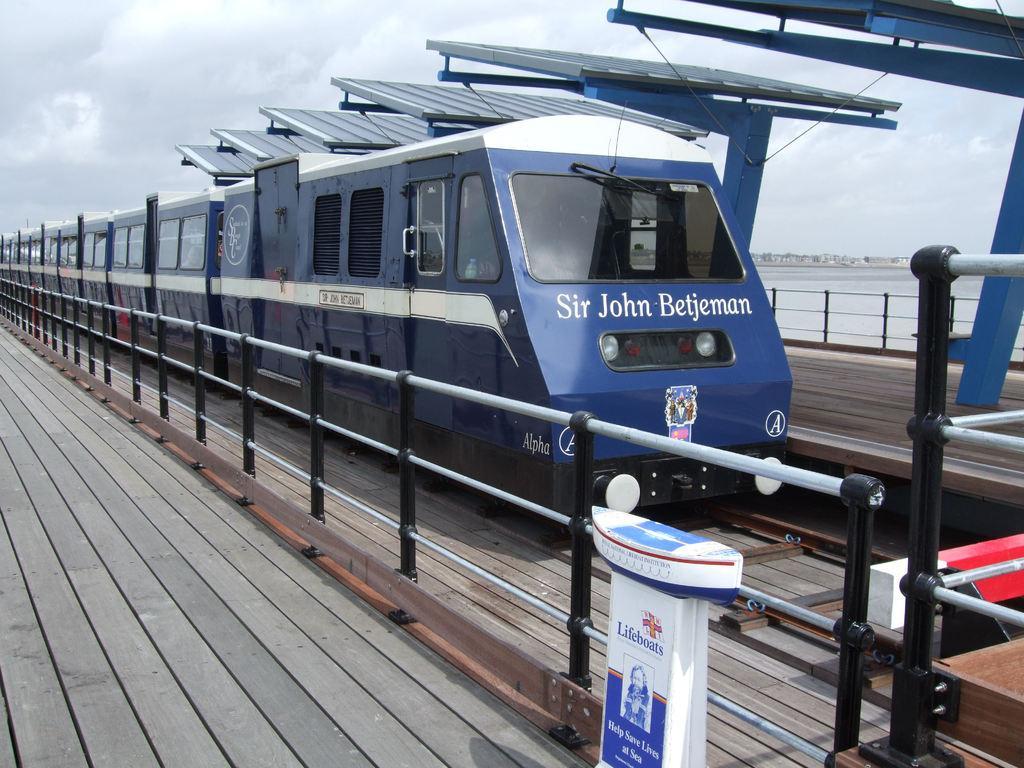Please provide a concise description of this image. In this image there is a train on the railway track and there are solar panels above it. There is fencing on either side of the train. On the left side there is a wooden floor beside the fencing. At the top there is sky. 